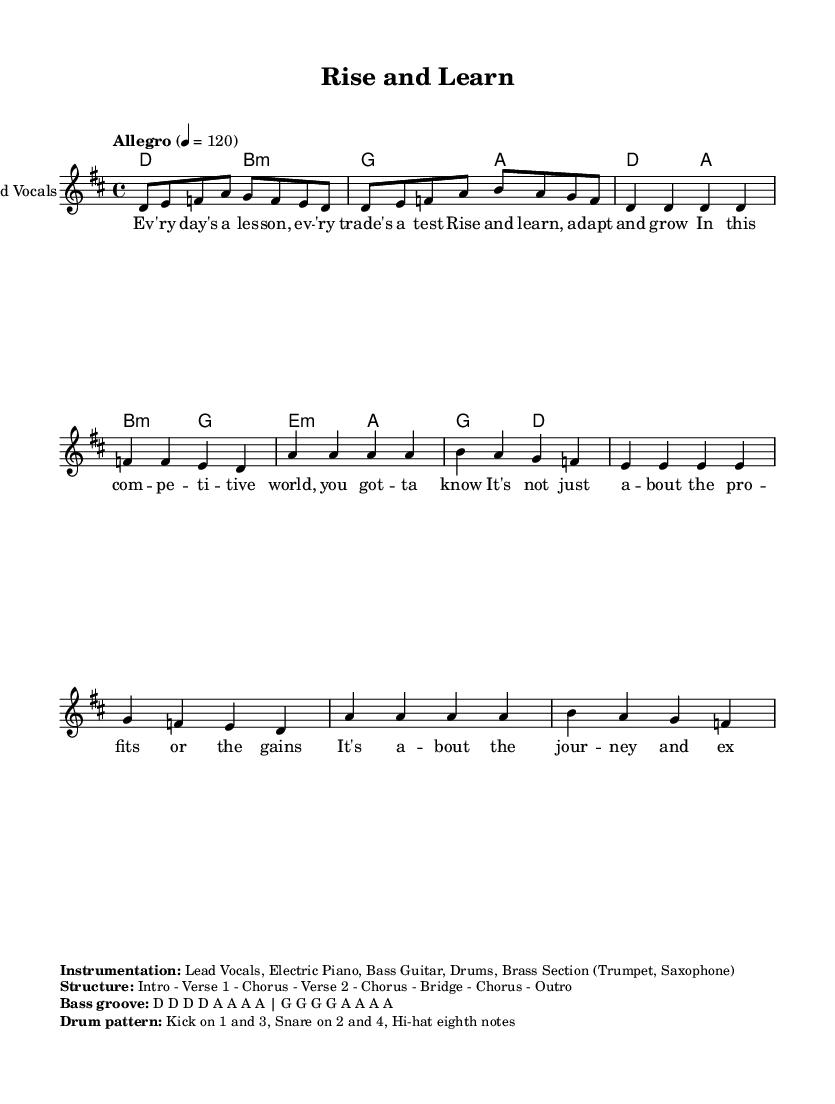What is the key signature of this music? The key signature is indicated at the beginning of the score. It is D major, which has two sharps (F# and C#).
Answer: D major What is the time signature of this music? The time signature is shown after the key signature, and it reads 4/4, which means there are four beats in a measure and a quarter note gets one beat.
Answer: 4/4 What is the tempo marking for this piece? The tempo is indicated in the score using the term "Allegro," with a metronome marking of 120 beats per minute, meaning it should be played quickly.
Answer: Allegro 4 = 120 How many verses are in the structure of this song? The structure lists an Intro, followed by Verse 1, Chorus, Verse 2, Chorus, Bridge, another Chorus, and finally an Outro. This adds up to two verses in the song.
Answer: Two What instruments are included in the instrumentation of the piece? The instrumentation is noted under the markup section and lists Lead Vocals, Electric Piano, Bass Guitar, Drums, and a Brass Section which includes Trumpet and Saxophone.
Answer: Lead Vocals, Electric Piano, Bass Guitar, Drums, Brass Section What kind of groove does the bass follow? The bass groove is described in the markup section, indicating it plays a repeated pattern that emphasizes the notes D and A. This shows its syncopation and rhythmic importance.
Answer: D D D D A A A A What is the primary theme expressed in the lyrics of this song? The lyrics focus on personal growth, adaptability, and the journey of continuous learning in a competitive environment. The mentions of lessons and expanding brains emphasize this theme.
Answer: Personal growth and continuous learning 